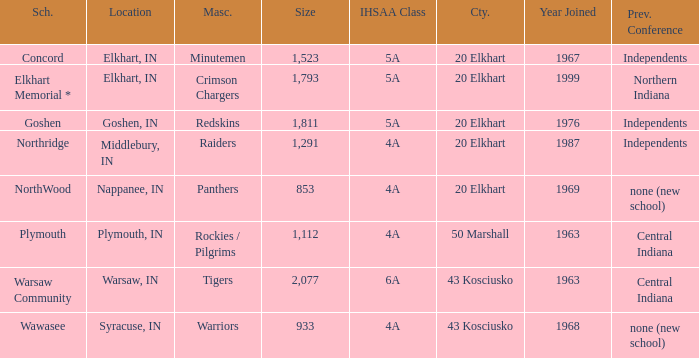What is the IHSAA class for the team located in Middlebury, IN? 4A. 